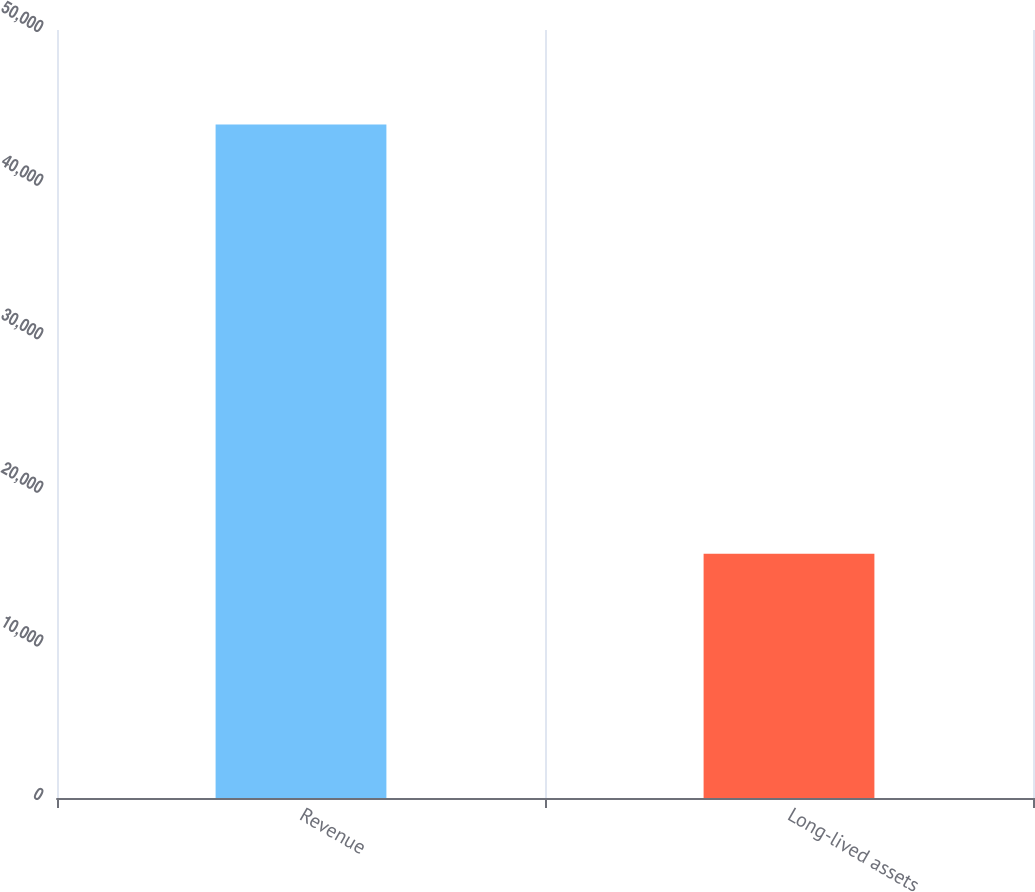Convert chart to OTSL. <chart><loc_0><loc_0><loc_500><loc_500><bar_chart><fcel>Revenue<fcel>Long-lived assets<nl><fcel>43840<fcel>15902<nl></chart> 